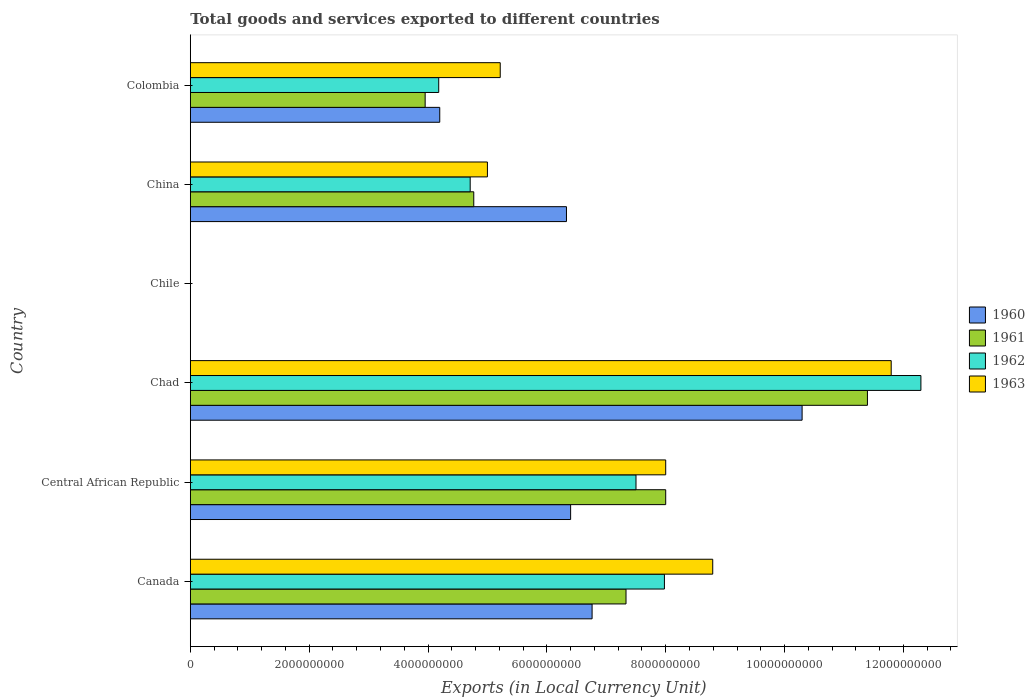How many bars are there on the 6th tick from the bottom?
Your answer should be compact. 4. What is the Amount of goods and services exports in 1963 in China?
Provide a succinct answer. 5.00e+09. Across all countries, what is the maximum Amount of goods and services exports in 1960?
Provide a succinct answer. 1.03e+1. Across all countries, what is the minimum Amount of goods and services exports in 1963?
Your answer should be very brief. 1.10e+06. In which country was the Amount of goods and services exports in 1961 maximum?
Offer a very short reply. Chad. In which country was the Amount of goods and services exports in 1962 minimum?
Offer a very short reply. Chile. What is the total Amount of goods and services exports in 1961 in the graph?
Give a very brief answer. 3.54e+1. What is the difference between the Amount of goods and services exports in 1960 in Canada and that in Colombia?
Keep it short and to the point. 2.56e+09. What is the difference between the Amount of goods and services exports in 1961 in Chile and the Amount of goods and services exports in 1962 in China?
Provide a succinct answer. -4.71e+09. What is the average Amount of goods and services exports in 1961 per country?
Your response must be concise. 5.91e+09. What is the difference between the Amount of goods and services exports in 1962 and Amount of goods and services exports in 1963 in Chad?
Your response must be concise. 5.00e+08. In how many countries, is the Amount of goods and services exports in 1961 greater than 4400000000 LCU?
Provide a short and direct response. 4. What is the ratio of the Amount of goods and services exports in 1960 in Canada to that in Colombia?
Keep it short and to the point. 1.61. What is the difference between the highest and the second highest Amount of goods and services exports in 1963?
Give a very brief answer. 3.00e+09. What is the difference between the highest and the lowest Amount of goods and services exports in 1961?
Your answer should be compact. 1.14e+1. In how many countries, is the Amount of goods and services exports in 1960 greater than the average Amount of goods and services exports in 1960 taken over all countries?
Your answer should be very brief. 4. Is the sum of the Amount of goods and services exports in 1960 in Canada and Colombia greater than the maximum Amount of goods and services exports in 1963 across all countries?
Keep it short and to the point. No. How many bars are there?
Offer a terse response. 24. Are all the bars in the graph horizontal?
Your answer should be very brief. Yes. How many countries are there in the graph?
Offer a very short reply. 6. What is the difference between two consecutive major ticks on the X-axis?
Your answer should be very brief. 2.00e+09. Does the graph contain grids?
Ensure brevity in your answer.  No. What is the title of the graph?
Offer a very short reply. Total goods and services exported to different countries. What is the label or title of the X-axis?
Give a very brief answer. Exports (in Local Currency Unit). What is the label or title of the Y-axis?
Your answer should be very brief. Country. What is the Exports (in Local Currency Unit) in 1960 in Canada?
Your answer should be very brief. 6.76e+09. What is the Exports (in Local Currency Unit) in 1961 in Canada?
Your answer should be very brief. 7.33e+09. What is the Exports (in Local Currency Unit) of 1962 in Canada?
Your answer should be compact. 7.98e+09. What is the Exports (in Local Currency Unit) of 1963 in Canada?
Your answer should be compact. 8.79e+09. What is the Exports (in Local Currency Unit) in 1960 in Central African Republic?
Your answer should be compact. 6.40e+09. What is the Exports (in Local Currency Unit) in 1961 in Central African Republic?
Your response must be concise. 8.00e+09. What is the Exports (in Local Currency Unit) of 1962 in Central African Republic?
Your answer should be very brief. 7.50e+09. What is the Exports (in Local Currency Unit) of 1963 in Central African Republic?
Offer a terse response. 8.00e+09. What is the Exports (in Local Currency Unit) of 1960 in Chad?
Your response must be concise. 1.03e+1. What is the Exports (in Local Currency Unit) of 1961 in Chad?
Provide a succinct answer. 1.14e+1. What is the Exports (in Local Currency Unit) in 1962 in Chad?
Keep it short and to the point. 1.23e+1. What is the Exports (in Local Currency Unit) in 1963 in Chad?
Offer a very short reply. 1.18e+1. What is the Exports (in Local Currency Unit) of 1960 in Chile?
Offer a terse response. 6.00e+05. What is the Exports (in Local Currency Unit) in 1963 in Chile?
Your response must be concise. 1.10e+06. What is the Exports (in Local Currency Unit) of 1960 in China?
Provide a succinct answer. 6.33e+09. What is the Exports (in Local Currency Unit) of 1961 in China?
Offer a very short reply. 4.77e+09. What is the Exports (in Local Currency Unit) in 1962 in China?
Your answer should be very brief. 4.71e+09. What is the Exports (in Local Currency Unit) of 1960 in Colombia?
Your answer should be very brief. 4.20e+09. What is the Exports (in Local Currency Unit) in 1961 in Colombia?
Make the answer very short. 3.95e+09. What is the Exports (in Local Currency Unit) of 1962 in Colombia?
Offer a very short reply. 4.18e+09. What is the Exports (in Local Currency Unit) of 1963 in Colombia?
Ensure brevity in your answer.  5.22e+09. Across all countries, what is the maximum Exports (in Local Currency Unit) of 1960?
Give a very brief answer. 1.03e+1. Across all countries, what is the maximum Exports (in Local Currency Unit) in 1961?
Ensure brevity in your answer.  1.14e+1. Across all countries, what is the maximum Exports (in Local Currency Unit) of 1962?
Offer a very short reply. 1.23e+1. Across all countries, what is the maximum Exports (in Local Currency Unit) of 1963?
Offer a terse response. 1.18e+1. Across all countries, what is the minimum Exports (in Local Currency Unit) in 1960?
Provide a short and direct response. 6.00e+05. Across all countries, what is the minimum Exports (in Local Currency Unit) of 1962?
Your response must be concise. 7.00e+05. Across all countries, what is the minimum Exports (in Local Currency Unit) of 1963?
Provide a succinct answer. 1.10e+06. What is the total Exports (in Local Currency Unit) in 1960 in the graph?
Give a very brief answer. 3.40e+1. What is the total Exports (in Local Currency Unit) in 1961 in the graph?
Give a very brief answer. 3.54e+1. What is the total Exports (in Local Currency Unit) of 1962 in the graph?
Offer a terse response. 3.67e+1. What is the total Exports (in Local Currency Unit) of 1963 in the graph?
Your answer should be compact. 3.88e+1. What is the difference between the Exports (in Local Currency Unit) in 1960 in Canada and that in Central African Republic?
Your response must be concise. 3.61e+08. What is the difference between the Exports (in Local Currency Unit) in 1961 in Canada and that in Central African Republic?
Your answer should be compact. -6.68e+08. What is the difference between the Exports (in Local Currency Unit) of 1962 in Canada and that in Central African Republic?
Ensure brevity in your answer.  4.78e+08. What is the difference between the Exports (in Local Currency Unit) in 1963 in Canada and that in Central African Republic?
Offer a very short reply. 7.91e+08. What is the difference between the Exports (in Local Currency Unit) in 1960 in Canada and that in Chad?
Provide a succinct answer. -3.53e+09. What is the difference between the Exports (in Local Currency Unit) in 1961 in Canada and that in Chad?
Provide a succinct answer. -4.06e+09. What is the difference between the Exports (in Local Currency Unit) of 1962 in Canada and that in Chad?
Keep it short and to the point. -4.32e+09. What is the difference between the Exports (in Local Currency Unit) in 1963 in Canada and that in Chad?
Give a very brief answer. -3.00e+09. What is the difference between the Exports (in Local Currency Unit) in 1960 in Canada and that in Chile?
Provide a succinct answer. 6.76e+09. What is the difference between the Exports (in Local Currency Unit) of 1961 in Canada and that in Chile?
Offer a very short reply. 7.33e+09. What is the difference between the Exports (in Local Currency Unit) of 1962 in Canada and that in Chile?
Make the answer very short. 7.98e+09. What is the difference between the Exports (in Local Currency Unit) of 1963 in Canada and that in Chile?
Your answer should be compact. 8.79e+09. What is the difference between the Exports (in Local Currency Unit) in 1960 in Canada and that in China?
Your response must be concise. 4.31e+08. What is the difference between the Exports (in Local Currency Unit) in 1961 in Canada and that in China?
Keep it short and to the point. 2.56e+09. What is the difference between the Exports (in Local Currency Unit) of 1962 in Canada and that in China?
Provide a succinct answer. 3.27e+09. What is the difference between the Exports (in Local Currency Unit) of 1963 in Canada and that in China?
Make the answer very short. 3.79e+09. What is the difference between the Exports (in Local Currency Unit) of 1960 in Canada and that in Colombia?
Your answer should be compact. 2.56e+09. What is the difference between the Exports (in Local Currency Unit) of 1961 in Canada and that in Colombia?
Ensure brevity in your answer.  3.38e+09. What is the difference between the Exports (in Local Currency Unit) of 1962 in Canada and that in Colombia?
Ensure brevity in your answer.  3.80e+09. What is the difference between the Exports (in Local Currency Unit) of 1963 in Canada and that in Colombia?
Provide a short and direct response. 3.58e+09. What is the difference between the Exports (in Local Currency Unit) in 1960 in Central African Republic and that in Chad?
Keep it short and to the point. -3.90e+09. What is the difference between the Exports (in Local Currency Unit) of 1961 in Central African Republic and that in Chad?
Keep it short and to the point. -3.39e+09. What is the difference between the Exports (in Local Currency Unit) of 1962 in Central African Republic and that in Chad?
Your answer should be compact. -4.79e+09. What is the difference between the Exports (in Local Currency Unit) of 1963 in Central African Republic and that in Chad?
Offer a very short reply. -3.79e+09. What is the difference between the Exports (in Local Currency Unit) of 1960 in Central African Republic and that in Chile?
Your answer should be compact. 6.40e+09. What is the difference between the Exports (in Local Currency Unit) of 1961 in Central African Republic and that in Chile?
Your answer should be compact. 8.00e+09. What is the difference between the Exports (in Local Currency Unit) of 1962 in Central African Republic and that in Chile?
Give a very brief answer. 7.50e+09. What is the difference between the Exports (in Local Currency Unit) in 1963 in Central African Republic and that in Chile?
Provide a succinct answer. 8.00e+09. What is the difference between the Exports (in Local Currency Unit) in 1960 in Central African Republic and that in China?
Your answer should be very brief. 7.00e+07. What is the difference between the Exports (in Local Currency Unit) in 1961 in Central African Republic and that in China?
Provide a short and direct response. 3.23e+09. What is the difference between the Exports (in Local Currency Unit) in 1962 in Central African Republic and that in China?
Offer a terse response. 2.79e+09. What is the difference between the Exports (in Local Currency Unit) in 1963 in Central African Republic and that in China?
Provide a short and direct response. 3.00e+09. What is the difference between the Exports (in Local Currency Unit) in 1960 in Central African Republic and that in Colombia?
Give a very brief answer. 2.20e+09. What is the difference between the Exports (in Local Currency Unit) in 1961 in Central African Republic and that in Colombia?
Offer a terse response. 4.05e+09. What is the difference between the Exports (in Local Currency Unit) in 1962 in Central African Republic and that in Colombia?
Offer a terse response. 3.32e+09. What is the difference between the Exports (in Local Currency Unit) in 1963 in Central African Republic and that in Colombia?
Your response must be concise. 2.78e+09. What is the difference between the Exports (in Local Currency Unit) of 1960 in Chad and that in Chile?
Provide a short and direct response. 1.03e+1. What is the difference between the Exports (in Local Currency Unit) in 1961 in Chad and that in Chile?
Give a very brief answer. 1.14e+1. What is the difference between the Exports (in Local Currency Unit) in 1962 in Chad and that in Chile?
Ensure brevity in your answer.  1.23e+1. What is the difference between the Exports (in Local Currency Unit) in 1963 in Chad and that in Chile?
Ensure brevity in your answer.  1.18e+1. What is the difference between the Exports (in Local Currency Unit) of 1960 in Chad and that in China?
Your response must be concise. 3.97e+09. What is the difference between the Exports (in Local Currency Unit) of 1961 in Chad and that in China?
Make the answer very short. 6.62e+09. What is the difference between the Exports (in Local Currency Unit) of 1962 in Chad and that in China?
Offer a terse response. 7.58e+09. What is the difference between the Exports (in Local Currency Unit) of 1963 in Chad and that in China?
Make the answer very short. 6.79e+09. What is the difference between the Exports (in Local Currency Unit) of 1960 in Chad and that in Colombia?
Give a very brief answer. 6.10e+09. What is the difference between the Exports (in Local Currency Unit) in 1961 in Chad and that in Colombia?
Offer a terse response. 7.44e+09. What is the difference between the Exports (in Local Currency Unit) in 1962 in Chad and that in Colombia?
Provide a short and direct response. 8.11e+09. What is the difference between the Exports (in Local Currency Unit) of 1963 in Chad and that in Colombia?
Provide a succinct answer. 6.58e+09. What is the difference between the Exports (in Local Currency Unit) in 1960 in Chile and that in China?
Your answer should be compact. -6.33e+09. What is the difference between the Exports (in Local Currency Unit) of 1961 in Chile and that in China?
Your response must be concise. -4.77e+09. What is the difference between the Exports (in Local Currency Unit) in 1962 in Chile and that in China?
Provide a succinct answer. -4.71e+09. What is the difference between the Exports (in Local Currency Unit) of 1963 in Chile and that in China?
Your response must be concise. -5.00e+09. What is the difference between the Exports (in Local Currency Unit) in 1960 in Chile and that in Colombia?
Offer a terse response. -4.20e+09. What is the difference between the Exports (in Local Currency Unit) of 1961 in Chile and that in Colombia?
Offer a very short reply. -3.95e+09. What is the difference between the Exports (in Local Currency Unit) of 1962 in Chile and that in Colombia?
Provide a short and direct response. -4.18e+09. What is the difference between the Exports (in Local Currency Unit) of 1963 in Chile and that in Colombia?
Offer a terse response. -5.21e+09. What is the difference between the Exports (in Local Currency Unit) in 1960 in China and that in Colombia?
Offer a terse response. 2.13e+09. What is the difference between the Exports (in Local Currency Unit) in 1961 in China and that in Colombia?
Make the answer very short. 8.18e+08. What is the difference between the Exports (in Local Currency Unit) in 1962 in China and that in Colombia?
Keep it short and to the point. 5.30e+08. What is the difference between the Exports (in Local Currency Unit) of 1963 in China and that in Colombia?
Offer a very short reply. -2.16e+08. What is the difference between the Exports (in Local Currency Unit) of 1960 in Canada and the Exports (in Local Currency Unit) of 1961 in Central African Republic?
Offer a very short reply. -1.24e+09. What is the difference between the Exports (in Local Currency Unit) in 1960 in Canada and the Exports (in Local Currency Unit) in 1962 in Central African Republic?
Give a very brief answer. -7.39e+08. What is the difference between the Exports (in Local Currency Unit) of 1960 in Canada and the Exports (in Local Currency Unit) of 1963 in Central African Republic?
Keep it short and to the point. -1.24e+09. What is the difference between the Exports (in Local Currency Unit) in 1961 in Canada and the Exports (in Local Currency Unit) in 1962 in Central African Republic?
Offer a very short reply. -1.68e+08. What is the difference between the Exports (in Local Currency Unit) in 1961 in Canada and the Exports (in Local Currency Unit) in 1963 in Central African Republic?
Provide a short and direct response. -6.68e+08. What is the difference between the Exports (in Local Currency Unit) in 1962 in Canada and the Exports (in Local Currency Unit) in 1963 in Central African Republic?
Provide a succinct answer. -2.17e+07. What is the difference between the Exports (in Local Currency Unit) in 1960 in Canada and the Exports (in Local Currency Unit) in 1961 in Chad?
Provide a short and direct response. -4.63e+09. What is the difference between the Exports (in Local Currency Unit) in 1960 in Canada and the Exports (in Local Currency Unit) in 1962 in Chad?
Give a very brief answer. -5.53e+09. What is the difference between the Exports (in Local Currency Unit) in 1960 in Canada and the Exports (in Local Currency Unit) in 1963 in Chad?
Give a very brief answer. -5.03e+09. What is the difference between the Exports (in Local Currency Unit) of 1961 in Canada and the Exports (in Local Currency Unit) of 1962 in Chad?
Offer a very short reply. -4.96e+09. What is the difference between the Exports (in Local Currency Unit) of 1961 in Canada and the Exports (in Local Currency Unit) of 1963 in Chad?
Make the answer very short. -4.46e+09. What is the difference between the Exports (in Local Currency Unit) of 1962 in Canada and the Exports (in Local Currency Unit) of 1963 in Chad?
Offer a very short reply. -3.82e+09. What is the difference between the Exports (in Local Currency Unit) in 1960 in Canada and the Exports (in Local Currency Unit) in 1961 in Chile?
Offer a terse response. 6.76e+09. What is the difference between the Exports (in Local Currency Unit) in 1960 in Canada and the Exports (in Local Currency Unit) in 1962 in Chile?
Your answer should be compact. 6.76e+09. What is the difference between the Exports (in Local Currency Unit) in 1960 in Canada and the Exports (in Local Currency Unit) in 1963 in Chile?
Ensure brevity in your answer.  6.76e+09. What is the difference between the Exports (in Local Currency Unit) of 1961 in Canada and the Exports (in Local Currency Unit) of 1962 in Chile?
Your answer should be very brief. 7.33e+09. What is the difference between the Exports (in Local Currency Unit) of 1961 in Canada and the Exports (in Local Currency Unit) of 1963 in Chile?
Provide a succinct answer. 7.33e+09. What is the difference between the Exports (in Local Currency Unit) in 1962 in Canada and the Exports (in Local Currency Unit) in 1963 in Chile?
Provide a succinct answer. 7.98e+09. What is the difference between the Exports (in Local Currency Unit) of 1960 in Canada and the Exports (in Local Currency Unit) of 1961 in China?
Your answer should be very brief. 1.99e+09. What is the difference between the Exports (in Local Currency Unit) of 1960 in Canada and the Exports (in Local Currency Unit) of 1962 in China?
Offer a terse response. 2.05e+09. What is the difference between the Exports (in Local Currency Unit) in 1960 in Canada and the Exports (in Local Currency Unit) in 1963 in China?
Make the answer very short. 1.76e+09. What is the difference between the Exports (in Local Currency Unit) in 1961 in Canada and the Exports (in Local Currency Unit) in 1962 in China?
Offer a very short reply. 2.62e+09. What is the difference between the Exports (in Local Currency Unit) in 1961 in Canada and the Exports (in Local Currency Unit) in 1963 in China?
Your response must be concise. 2.33e+09. What is the difference between the Exports (in Local Currency Unit) of 1962 in Canada and the Exports (in Local Currency Unit) of 1963 in China?
Give a very brief answer. 2.98e+09. What is the difference between the Exports (in Local Currency Unit) in 1960 in Canada and the Exports (in Local Currency Unit) in 1961 in Colombia?
Give a very brief answer. 2.81e+09. What is the difference between the Exports (in Local Currency Unit) of 1960 in Canada and the Exports (in Local Currency Unit) of 1962 in Colombia?
Your response must be concise. 2.58e+09. What is the difference between the Exports (in Local Currency Unit) in 1960 in Canada and the Exports (in Local Currency Unit) in 1963 in Colombia?
Your answer should be compact. 1.55e+09. What is the difference between the Exports (in Local Currency Unit) in 1961 in Canada and the Exports (in Local Currency Unit) in 1962 in Colombia?
Keep it short and to the point. 3.15e+09. What is the difference between the Exports (in Local Currency Unit) in 1961 in Canada and the Exports (in Local Currency Unit) in 1963 in Colombia?
Your answer should be very brief. 2.12e+09. What is the difference between the Exports (in Local Currency Unit) of 1962 in Canada and the Exports (in Local Currency Unit) of 1963 in Colombia?
Make the answer very short. 2.76e+09. What is the difference between the Exports (in Local Currency Unit) of 1960 in Central African Republic and the Exports (in Local Currency Unit) of 1961 in Chad?
Provide a succinct answer. -4.99e+09. What is the difference between the Exports (in Local Currency Unit) of 1960 in Central African Republic and the Exports (in Local Currency Unit) of 1962 in Chad?
Your response must be concise. -5.89e+09. What is the difference between the Exports (in Local Currency Unit) of 1960 in Central African Republic and the Exports (in Local Currency Unit) of 1963 in Chad?
Provide a short and direct response. -5.39e+09. What is the difference between the Exports (in Local Currency Unit) in 1961 in Central African Republic and the Exports (in Local Currency Unit) in 1962 in Chad?
Give a very brief answer. -4.29e+09. What is the difference between the Exports (in Local Currency Unit) of 1961 in Central African Republic and the Exports (in Local Currency Unit) of 1963 in Chad?
Your answer should be compact. -3.79e+09. What is the difference between the Exports (in Local Currency Unit) of 1962 in Central African Republic and the Exports (in Local Currency Unit) of 1963 in Chad?
Ensure brevity in your answer.  -4.29e+09. What is the difference between the Exports (in Local Currency Unit) of 1960 in Central African Republic and the Exports (in Local Currency Unit) of 1961 in Chile?
Keep it short and to the point. 6.40e+09. What is the difference between the Exports (in Local Currency Unit) in 1960 in Central African Republic and the Exports (in Local Currency Unit) in 1962 in Chile?
Keep it short and to the point. 6.40e+09. What is the difference between the Exports (in Local Currency Unit) of 1960 in Central African Republic and the Exports (in Local Currency Unit) of 1963 in Chile?
Your answer should be very brief. 6.40e+09. What is the difference between the Exports (in Local Currency Unit) of 1961 in Central African Republic and the Exports (in Local Currency Unit) of 1962 in Chile?
Offer a very short reply. 8.00e+09. What is the difference between the Exports (in Local Currency Unit) in 1961 in Central African Republic and the Exports (in Local Currency Unit) in 1963 in Chile?
Ensure brevity in your answer.  8.00e+09. What is the difference between the Exports (in Local Currency Unit) of 1962 in Central African Republic and the Exports (in Local Currency Unit) of 1963 in Chile?
Your response must be concise. 7.50e+09. What is the difference between the Exports (in Local Currency Unit) in 1960 in Central African Republic and the Exports (in Local Currency Unit) in 1961 in China?
Provide a succinct answer. 1.63e+09. What is the difference between the Exports (in Local Currency Unit) of 1960 in Central African Republic and the Exports (in Local Currency Unit) of 1962 in China?
Provide a succinct answer. 1.69e+09. What is the difference between the Exports (in Local Currency Unit) of 1960 in Central African Republic and the Exports (in Local Currency Unit) of 1963 in China?
Make the answer very short. 1.40e+09. What is the difference between the Exports (in Local Currency Unit) of 1961 in Central African Republic and the Exports (in Local Currency Unit) of 1962 in China?
Offer a terse response. 3.29e+09. What is the difference between the Exports (in Local Currency Unit) in 1961 in Central African Republic and the Exports (in Local Currency Unit) in 1963 in China?
Keep it short and to the point. 3.00e+09. What is the difference between the Exports (in Local Currency Unit) of 1962 in Central African Republic and the Exports (in Local Currency Unit) of 1963 in China?
Offer a very short reply. 2.50e+09. What is the difference between the Exports (in Local Currency Unit) in 1960 in Central African Republic and the Exports (in Local Currency Unit) in 1961 in Colombia?
Ensure brevity in your answer.  2.45e+09. What is the difference between the Exports (in Local Currency Unit) of 1960 in Central African Republic and the Exports (in Local Currency Unit) of 1962 in Colombia?
Ensure brevity in your answer.  2.22e+09. What is the difference between the Exports (in Local Currency Unit) of 1960 in Central African Republic and the Exports (in Local Currency Unit) of 1963 in Colombia?
Offer a very short reply. 1.18e+09. What is the difference between the Exports (in Local Currency Unit) in 1961 in Central African Republic and the Exports (in Local Currency Unit) in 1962 in Colombia?
Offer a very short reply. 3.82e+09. What is the difference between the Exports (in Local Currency Unit) in 1961 in Central African Republic and the Exports (in Local Currency Unit) in 1963 in Colombia?
Provide a succinct answer. 2.78e+09. What is the difference between the Exports (in Local Currency Unit) in 1962 in Central African Republic and the Exports (in Local Currency Unit) in 1963 in Colombia?
Your answer should be very brief. 2.28e+09. What is the difference between the Exports (in Local Currency Unit) in 1960 in Chad and the Exports (in Local Currency Unit) in 1961 in Chile?
Ensure brevity in your answer.  1.03e+1. What is the difference between the Exports (in Local Currency Unit) of 1960 in Chad and the Exports (in Local Currency Unit) of 1962 in Chile?
Provide a short and direct response. 1.03e+1. What is the difference between the Exports (in Local Currency Unit) in 1960 in Chad and the Exports (in Local Currency Unit) in 1963 in Chile?
Keep it short and to the point. 1.03e+1. What is the difference between the Exports (in Local Currency Unit) of 1961 in Chad and the Exports (in Local Currency Unit) of 1962 in Chile?
Offer a terse response. 1.14e+1. What is the difference between the Exports (in Local Currency Unit) in 1961 in Chad and the Exports (in Local Currency Unit) in 1963 in Chile?
Your response must be concise. 1.14e+1. What is the difference between the Exports (in Local Currency Unit) of 1962 in Chad and the Exports (in Local Currency Unit) of 1963 in Chile?
Provide a short and direct response. 1.23e+1. What is the difference between the Exports (in Local Currency Unit) in 1960 in Chad and the Exports (in Local Currency Unit) in 1961 in China?
Your response must be concise. 5.53e+09. What is the difference between the Exports (in Local Currency Unit) in 1960 in Chad and the Exports (in Local Currency Unit) in 1962 in China?
Make the answer very short. 5.59e+09. What is the difference between the Exports (in Local Currency Unit) in 1960 in Chad and the Exports (in Local Currency Unit) in 1963 in China?
Offer a very short reply. 5.30e+09. What is the difference between the Exports (in Local Currency Unit) in 1961 in Chad and the Exports (in Local Currency Unit) in 1962 in China?
Your answer should be very brief. 6.68e+09. What is the difference between the Exports (in Local Currency Unit) of 1961 in Chad and the Exports (in Local Currency Unit) of 1963 in China?
Keep it short and to the point. 6.39e+09. What is the difference between the Exports (in Local Currency Unit) of 1962 in Chad and the Exports (in Local Currency Unit) of 1963 in China?
Make the answer very short. 7.29e+09. What is the difference between the Exports (in Local Currency Unit) of 1960 in Chad and the Exports (in Local Currency Unit) of 1961 in Colombia?
Keep it short and to the point. 6.34e+09. What is the difference between the Exports (in Local Currency Unit) of 1960 in Chad and the Exports (in Local Currency Unit) of 1962 in Colombia?
Make the answer very short. 6.11e+09. What is the difference between the Exports (in Local Currency Unit) in 1960 in Chad and the Exports (in Local Currency Unit) in 1963 in Colombia?
Your answer should be compact. 5.08e+09. What is the difference between the Exports (in Local Currency Unit) in 1961 in Chad and the Exports (in Local Currency Unit) in 1962 in Colombia?
Offer a terse response. 7.21e+09. What is the difference between the Exports (in Local Currency Unit) in 1961 in Chad and the Exports (in Local Currency Unit) in 1963 in Colombia?
Ensure brevity in your answer.  6.18e+09. What is the difference between the Exports (in Local Currency Unit) in 1962 in Chad and the Exports (in Local Currency Unit) in 1963 in Colombia?
Ensure brevity in your answer.  7.08e+09. What is the difference between the Exports (in Local Currency Unit) of 1960 in Chile and the Exports (in Local Currency Unit) of 1961 in China?
Your answer should be compact. -4.77e+09. What is the difference between the Exports (in Local Currency Unit) in 1960 in Chile and the Exports (in Local Currency Unit) in 1962 in China?
Keep it short and to the point. -4.71e+09. What is the difference between the Exports (in Local Currency Unit) of 1960 in Chile and the Exports (in Local Currency Unit) of 1963 in China?
Offer a terse response. -5.00e+09. What is the difference between the Exports (in Local Currency Unit) in 1961 in Chile and the Exports (in Local Currency Unit) in 1962 in China?
Your answer should be compact. -4.71e+09. What is the difference between the Exports (in Local Currency Unit) in 1961 in Chile and the Exports (in Local Currency Unit) in 1963 in China?
Your answer should be very brief. -5.00e+09. What is the difference between the Exports (in Local Currency Unit) in 1962 in Chile and the Exports (in Local Currency Unit) in 1963 in China?
Keep it short and to the point. -5.00e+09. What is the difference between the Exports (in Local Currency Unit) of 1960 in Chile and the Exports (in Local Currency Unit) of 1961 in Colombia?
Provide a short and direct response. -3.95e+09. What is the difference between the Exports (in Local Currency Unit) in 1960 in Chile and the Exports (in Local Currency Unit) in 1962 in Colombia?
Keep it short and to the point. -4.18e+09. What is the difference between the Exports (in Local Currency Unit) of 1960 in Chile and the Exports (in Local Currency Unit) of 1963 in Colombia?
Your answer should be compact. -5.21e+09. What is the difference between the Exports (in Local Currency Unit) in 1961 in Chile and the Exports (in Local Currency Unit) in 1962 in Colombia?
Offer a very short reply. -4.18e+09. What is the difference between the Exports (in Local Currency Unit) of 1961 in Chile and the Exports (in Local Currency Unit) of 1963 in Colombia?
Make the answer very short. -5.21e+09. What is the difference between the Exports (in Local Currency Unit) in 1962 in Chile and the Exports (in Local Currency Unit) in 1963 in Colombia?
Your answer should be very brief. -5.21e+09. What is the difference between the Exports (in Local Currency Unit) of 1960 in China and the Exports (in Local Currency Unit) of 1961 in Colombia?
Offer a terse response. 2.38e+09. What is the difference between the Exports (in Local Currency Unit) in 1960 in China and the Exports (in Local Currency Unit) in 1962 in Colombia?
Offer a terse response. 2.15e+09. What is the difference between the Exports (in Local Currency Unit) of 1960 in China and the Exports (in Local Currency Unit) of 1963 in Colombia?
Keep it short and to the point. 1.11e+09. What is the difference between the Exports (in Local Currency Unit) of 1961 in China and the Exports (in Local Currency Unit) of 1962 in Colombia?
Make the answer very short. 5.90e+08. What is the difference between the Exports (in Local Currency Unit) of 1961 in China and the Exports (in Local Currency Unit) of 1963 in Colombia?
Your response must be concise. -4.46e+08. What is the difference between the Exports (in Local Currency Unit) of 1962 in China and the Exports (in Local Currency Unit) of 1963 in Colombia?
Your answer should be very brief. -5.06e+08. What is the average Exports (in Local Currency Unit) in 1960 per country?
Your response must be concise. 5.66e+09. What is the average Exports (in Local Currency Unit) of 1961 per country?
Your answer should be compact. 5.91e+09. What is the average Exports (in Local Currency Unit) in 1962 per country?
Ensure brevity in your answer.  6.11e+09. What is the average Exports (in Local Currency Unit) of 1963 per country?
Your answer should be very brief. 6.47e+09. What is the difference between the Exports (in Local Currency Unit) in 1960 and Exports (in Local Currency Unit) in 1961 in Canada?
Keep it short and to the point. -5.71e+08. What is the difference between the Exports (in Local Currency Unit) in 1960 and Exports (in Local Currency Unit) in 1962 in Canada?
Ensure brevity in your answer.  -1.22e+09. What is the difference between the Exports (in Local Currency Unit) in 1960 and Exports (in Local Currency Unit) in 1963 in Canada?
Your response must be concise. -2.03e+09. What is the difference between the Exports (in Local Currency Unit) in 1961 and Exports (in Local Currency Unit) in 1962 in Canada?
Offer a terse response. -6.46e+08. What is the difference between the Exports (in Local Currency Unit) of 1961 and Exports (in Local Currency Unit) of 1963 in Canada?
Your answer should be compact. -1.46e+09. What is the difference between the Exports (in Local Currency Unit) in 1962 and Exports (in Local Currency Unit) in 1963 in Canada?
Provide a succinct answer. -8.13e+08. What is the difference between the Exports (in Local Currency Unit) of 1960 and Exports (in Local Currency Unit) of 1961 in Central African Republic?
Provide a succinct answer. -1.60e+09. What is the difference between the Exports (in Local Currency Unit) of 1960 and Exports (in Local Currency Unit) of 1962 in Central African Republic?
Provide a short and direct response. -1.10e+09. What is the difference between the Exports (in Local Currency Unit) in 1960 and Exports (in Local Currency Unit) in 1963 in Central African Republic?
Provide a short and direct response. -1.60e+09. What is the difference between the Exports (in Local Currency Unit) in 1961 and Exports (in Local Currency Unit) in 1962 in Central African Republic?
Offer a very short reply. 5.00e+08. What is the difference between the Exports (in Local Currency Unit) of 1962 and Exports (in Local Currency Unit) of 1963 in Central African Republic?
Provide a short and direct response. -5.00e+08. What is the difference between the Exports (in Local Currency Unit) in 1960 and Exports (in Local Currency Unit) in 1961 in Chad?
Make the answer very short. -1.10e+09. What is the difference between the Exports (in Local Currency Unit) in 1960 and Exports (in Local Currency Unit) in 1962 in Chad?
Keep it short and to the point. -2.00e+09. What is the difference between the Exports (in Local Currency Unit) in 1960 and Exports (in Local Currency Unit) in 1963 in Chad?
Keep it short and to the point. -1.50e+09. What is the difference between the Exports (in Local Currency Unit) of 1961 and Exports (in Local Currency Unit) of 1962 in Chad?
Your response must be concise. -9.00e+08. What is the difference between the Exports (in Local Currency Unit) in 1961 and Exports (in Local Currency Unit) in 1963 in Chad?
Provide a short and direct response. -4.00e+08. What is the difference between the Exports (in Local Currency Unit) in 1962 and Exports (in Local Currency Unit) in 1963 in Chad?
Provide a succinct answer. 5.00e+08. What is the difference between the Exports (in Local Currency Unit) in 1960 and Exports (in Local Currency Unit) in 1961 in Chile?
Provide a succinct answer. 0. What is the difference between the Exports (in Local Currency Unit) of 1960 and Exports (in Local Currency Unit) of 1962 in Chile?
Give a very brief answer. -1.00e+05. What is the difference between the Exports (in Local Currency Unit) in 1960 and Exports (in Local Currency Unit) in 1963 in Chile?
Your answer should be compact. -5.00e+05. What is the difference between the Exports (in Local Currency Unit) in 1961 and Exports (in Local Currency Unit) in 1962 in Chile?
Your answer should be compact. -1.00e+05. What is the difference between the Exports (in Local Currency Unit) in 1961 and Exports (in Local Currency Unit) in 1963 in Chile?
Ensure brevity in your answer.  -5.00e+05. What is the difference between the Exports (in Local Currency Unit) in 1962 and Exports (in Local Currency Unit) in 1963 in Chile?
Ensure brevity in your answer.  -4.00e+05. What is the difference between the Exports (in Local Currency Unit) of 1960 and Exports (in Local Currency Unit) of 1961 in China?
Provide a succinct answer. 1.56e+09. What is the difference between the Exports (in Local Currency Unit) of 1960 and Exports (in Local Currency Unit) of 1962 in China?
Keep it short and to the point. 1.62e+09. What is the difference between the Exports (in Local Currency Unit) in 1960 and Exports (in Local Currency Unit) in 1963 in China?
Ensure brevity in your answer.  1.33e+09. What is the difference between the Exports (in Local Currency Unit) in 1961 and Exports (in Local Currency Unit) in 1962 in China?
Your response must be concise. 6.00e+07. What is the difference between the Exports (in Local Currency Unit) of 1961 and Exports (in Local Currency Unit) of 1963 in China?
Provide a short and direct response. -2.30e+08. What is the difference between the Exports (in Local Currency Unit) of 1962 and Exports (in Local Currency Unit) of 1963 in China?
Make the answer very short. -2.90e+08. What is the difference between the Exports (in Local Currency Unit) in 1960 and Exports (in Local Currency Unit) in 1961 in Colombia?
Your answer should be compact. 2.46e+08. What is the difference between the Exports (in Local Currency Unit) in 1960 and Exports (in Local Currency Unit) in 1962 in Colombia?
Offer a very short reply. 1.74e+07. What is the difference between the Exports (in Local Currency Unit) in 1960 and Exports (in Local Currency Unit) in 1963 in Colombia?
Your answer should be very brief. -1.02e+09. What is the difference between the Exports (in Local Currency Unit) of 1961 and Exports (in Local Currency Unit) of 1962 in Colombia?
Provide a short and direct response. -2.28e+08. What is the difference between the Exports (in Local Currency Unit) in 1961 and Exports (in Local Currency Unit) in 1963 in Colombia?
Your answer should be very brief. -1.26e+09. What is the difference between the Exports (in Local Currency Unit) in 1962 and Exports (in Local Currency Unit) in 1963 in Colombia?
Offer a very short reply. -1.04e+09. What is the ratio of the Exports (in Local Currency Unit) in 1960 in Canada to that in Central African Republic?
Offer a terse response. 1.06. What is the ratio of the Exports (in Local Currency Unit) in 1961 in Canada to that in Central African Republic?
Offer a terse response. 0.92. What is the ratio of the Exports (in Local Currency Unit) in 1962 in Canada to that in Central African Republic?
Your answer should be very brief. 1.06. What is the ratio of the Exports (in Local Currency Unit) in 1963 in Canada to that in Central African Republic?
Your answer should be very brief. 1.1. What is the ratio of the Exports (in Local Currency Unit) in 1960 in Canada to that in Chad?
Give a very brief answer. 0.66. What is the ratio of the Exports (in Local Currency Unit) in 1961 in Canada to that in Chad?
Provide a short and direct response. 0.64. What is the ratio of the Exports (in Local Currency Unit) of 1962 in Canada to that in Chad?
Provide a succinct answer. 0.65. What is the ratio of the Exports (in Local Currency Unit) in 1963 in Canada to that in Chad?
Provide a succinct answer. 0.75. What is the ratio of the Exports (in Local Currency Unit) of 1960 in Canada to that in Chile?
Provide a succinct answer. 1.13e+04. What is the ratio of the Exports (in Local Currency Unit) in 1961 in Canada to that in Chile?
Keep it short and to the point. 1.22e+04. What is the ratio of the Exports (in Local Currency Unit) of 1962 in Canada to that in Chile?
Your response must be concise. 1.14e+04. What is the ratio of the Exports (in Local Currency Unit) of 1963 in Canada to that in Chile?
Offer a terse response. 7992.05. What is the ratio of the Exports (in Local Currency Unit) of 1960 in Canada to that in China?
Ensure brevity in your answer.  1.07. What is the ratio of the Exports (in Local Currency Unit) of 1961 in Canada to that in China?
Offer a terse response. 1.54. What is the ratio of the Exports (in Local Currency Unit) in 1962 in Canada to that in China?
Ensure brevity in your answer.  1.69. What is the ratio of the Exports (in Local Currency Unit) of 1963 in Canada to that in China?
Your answer should be very brief. 1.76. What is the ratio of the Exports (in Local Currency Unit) in 1960 in Canada to that in Colombia?
Keep it short and to the point. 1.61. What is the ratio of the Exports (in Local Currency Unit) in 1961 in Canada to that in Colombia?
Provide a succinct answer. 1.86. What is the ratio of the Exports (in Local Currency Unit) of 1962 in Canada to that in Colombia?
Your answer should be compact. 1.91. What is the ratio of the Exports (in Local Currency Unit) of 1963 in Canada to that in Colombia?
Provide a succinct answer. 1.69. What is the ratio of the Exports (in Local Currency Unit) of 1960 in Central African Republic to that in Chad?
Your answer should be compact. 0.62. What is the ratio of the Exports (in Local Currency Unit) in 1961 in Central African Republic to that in Chad?
Offer a terse response. 0.7. What is the ratio of the Exports (in Local Currency Unit) in 1962 in Central African Republic to that in Chad?
Your response must be concise. 0.61. What is the ratio of the Exports (in Local Currency Unit) in 1963 in Central African Republic to that in Chad?
Your response must be concise. 0.68. What is the ratio of the Exports (in Local Currency Unit) of 1960 in Central African Republic to that in Chile?
Offer a terse response. 1.07e+04. What is the ratio of the Exports (in Local Currency Unit) of 1961 in Central African Republic to that in Chile?
Make the answer very short. 1.33e+04. What is the ratio of the Exports (in Local Currency Unit) in 1962 in Central African Republic to that in Chile?
Offer a terse response. 1.07e+04. What is the ratio of the Exports (in Local Currency Unit) of 1963 in Central African Republic to that in Chile?
Offer a terse response. 7272.73. What is the ratio of the Exports (in Local Currency Unit) in 1960 in Central African Republic to that in China?
Ensure brevity in your answer.  1.01. What is the ratio of the Exports (in Local Currency Unit) of 1961 in Central African Republic to that in China?
Provide a succinct answer. 1.68. What is the ratio of the Exports (in Local Currency Unit) of 1962 in Central African Republic to that in China?
Keep it short and to the point. 1.59. What is the ratio of the Exports (in Local Currency Unit) in 1963 in Central African Republic to that in China?
Your response must be concise. 1.6. What is the ratio of the Exports (in Local Currency Unit) of 1960 in Central African Republic to that in Colombia?
Offer a terse response. 1.52. What is the ratio of the Exports (in Local Currency Unit) of 1961 in Central African Republic to that in Colombia?
Your answer should be compact. 2.02. What is the ratio of the Exports (in Local Currency Unit) of 1962 in Central African Republic to that in Colombia?
Give a very brief answer. 1.79. What is the ratio of the Exports (in Local Currency Unit) of 1963 in Central African Republic to that in Colombia?
Provide a succinct answer. 1.53. What is the ratio of the Exports (in Local Currency Unit) in 1960 in Chad to that in Chile?
Ensure brevity in your answer.  1.72e+04. What is the ratio of the Exports (in Local Currency Unit) in 1961 in Chad to that in Chile?
Offer a terse response. 1.90e+04. What is the ratio of the Exports (in Local Currency Unit) in 1962 in Chad to that in Chile?
Your response must be concise. 1.76e+04. What is the ratio of the Exports (in Local Currency Unit) of 1963 in Chad to that in Chile?
Your response must be concise. 1.07e+04. What is the ratio of the Exports (in Local Currency Unit) of 1960 in Chad to that in China?
Your answer should be compact. 1.63. What is the ratio of the Exports (in Local Currency Unit) in 1961 in Chad to that in China?
Make the answer very short. 2.39. What is the ratio of the Exports (in Local Currency Unit) in 1962 in Chad to that in China?
Ensure brevity in your answer.  2.61. What is the ratio of the Exports (in Local Currency Unit) in 1963 in Chad to that in China?
Offer a very short reply. 2.36. What is the ratio of the Exports (in Local Currency Unit) of 1960 in Chad to that in Colombia?
Provide a succinct answer. 2.45. What is the ratio of the Exports (in Local Currency Unit) of 1961 in Chad to that in Colombia?
Give a very brief answer. 2.88. What is the ratio of the Exports (in Local Currency Unit) of 1962 in Chad to that in Colombia?
Your answer should be very brief. 2.94. What is the ratio of the Exports (in Local Currency Unit) in 1963 in Chad to that in Colombia?
Your answer should be compact. 2.26. What is the ratio of the Exports (in Local Currency Unit) of 1960 in Chile to that in China?
Give a very brief answer. 0. What is the ratio of the Exports (in Local Currency Unit) in 1961 in Chile to that in China?
Ensure brevity in your answer.  0. What is the ratio of the Exports (in Local Currency Unit) of 1962 in Chile to that in China?
Keep it short and to the point. 0. What is the ratio of the Exports (in Local Currency Unit) in 1963 in Chile to that in China?
Provide a short and direct response. 0. What is the ratio of the Exports (in Local Currency Unit) of 1960 in China to that in Colombia?
Your response must be concise. 1.51. What is the ratio of the Exports (in Local Currency Unit) in 1961 in China to that in Colombia?
Offer a very short reply. 1.21. What is the ratio of the Exports (in Local Currency Unit) in 1962 in China to that in Colombia?
Ensure brevity in your answer.  1.13. What is the ratio of the Exports (in Local Currency Unit) in 1963 in China to that in Colombia?
Your answer should be very brief. 0.96. What is the difference between the highest and the second highest Exports (in Local Currency Unit) of 1960?
Keep it short and to the point. 3.53e+09. What is the difference between the highest and the second highest Exports (in Local Currency Unit) of 1961?
Provide a succinct answer. 3.39e+09. What is the difference between the highest and the second highest Exports (in Local Currency Unit) in 1962?
Keep it short and to the point. 4.32e+09. What is the difference between the highest and the second highest Exports (in Local Currency Unit) in 1963?
Provide a succinct answer. 3.00e+09. What is the difference between the highest and the lowest Exports (in Local Currency Unit) of 1960?
Offer a terse response. 1.03e+1. What is the difference between the highest and the lowest Exports (in Local Currency Unit) of 1961?
Offer a terse response. 1.14e+1. What is the difference between the highest and the lowest Exports (in Local Currency Unit) in 1962?
Ensure brevity in your answer.  1.23e+1. What is the difference between the highest and the lowest Exports (in Local Currency Unit) of 1963?
Keep it short and to the point. 1.18e+1. 